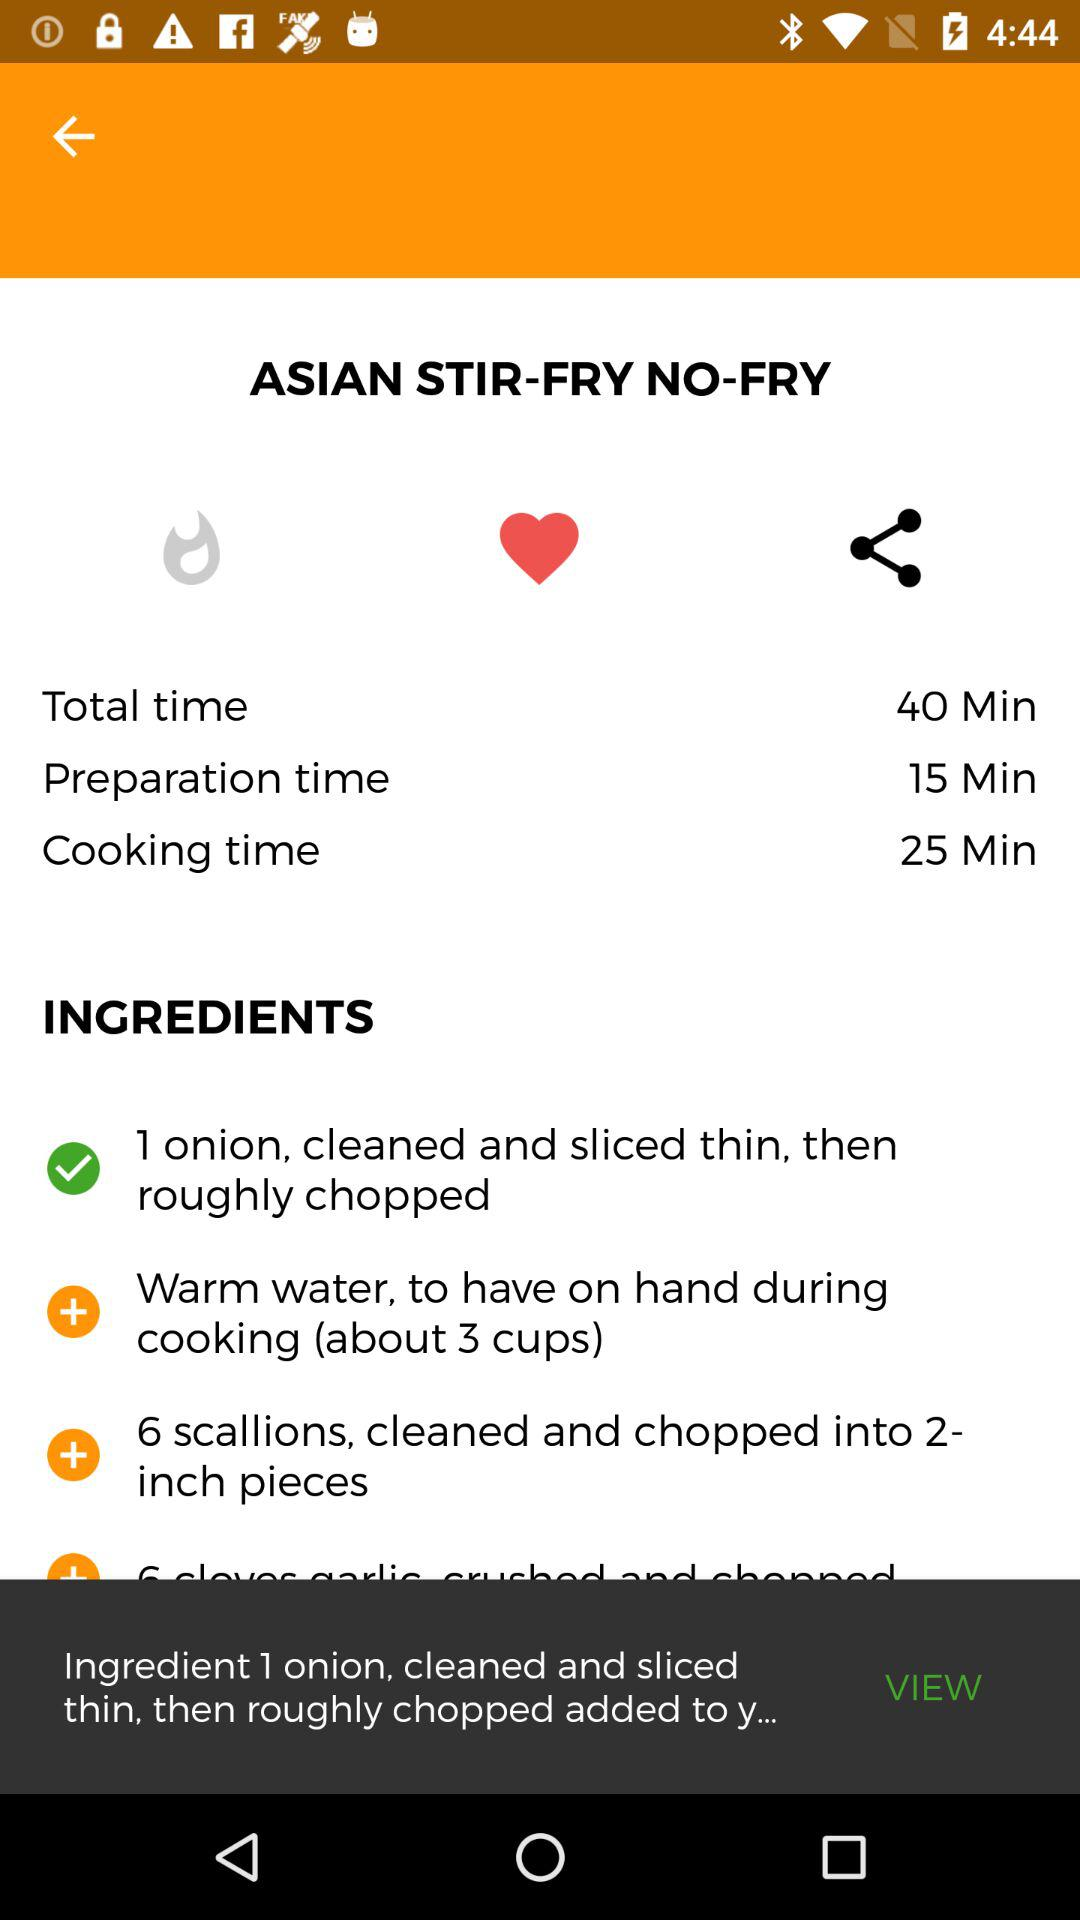What is the dish name? The dish name is "ASIAN STIR-FRY NO-FRY". 